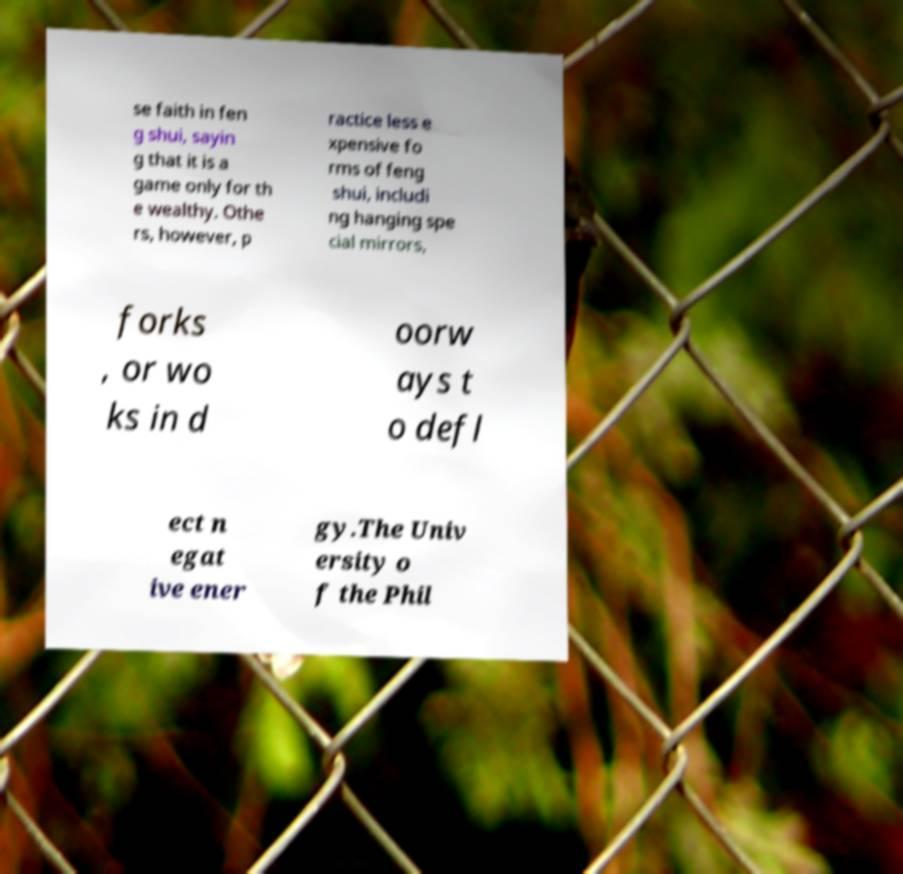Could you assist in decoding the text presented in this image and type it out clearly? se faith in fen g shui, sayin g that it is a game only for th e wealthy. Othe rs, however, p ractice less e xpensive fo rms of feng shui, includi ng hanging spe cial mirrors, forks , or wo ks in d oorw ays t o defl ect n egat ive ener gy.The Univ ersity o f the Phil 